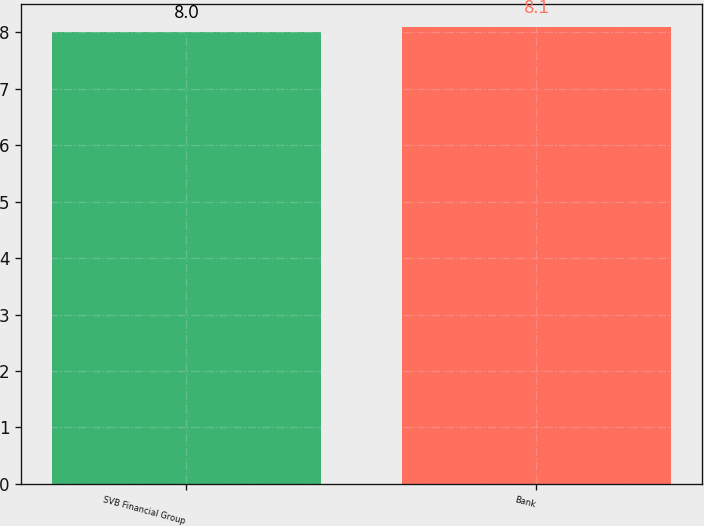Convert chart. <chart><loc_0><loc_0><loc_500><loc_500><bar_chart><fcel>SVB Financial Group<fcel>Bank<nl><fcel>8<fcel>8.1<nl></chart> 